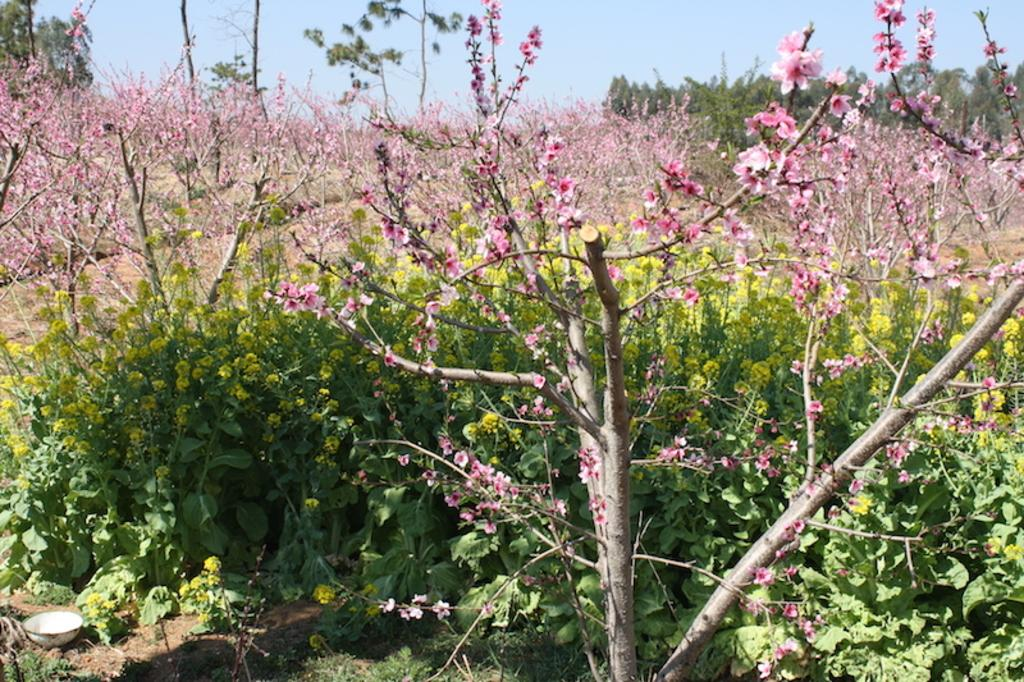What is the main subject of the image? The main subject of the image is many plants. What can be observed about the plants in the image? The plants have flowers. Is there a surprise party happening near the lake in the image? There is no mention of a surprise party or a lake in the image; it only features plants with flowers. 